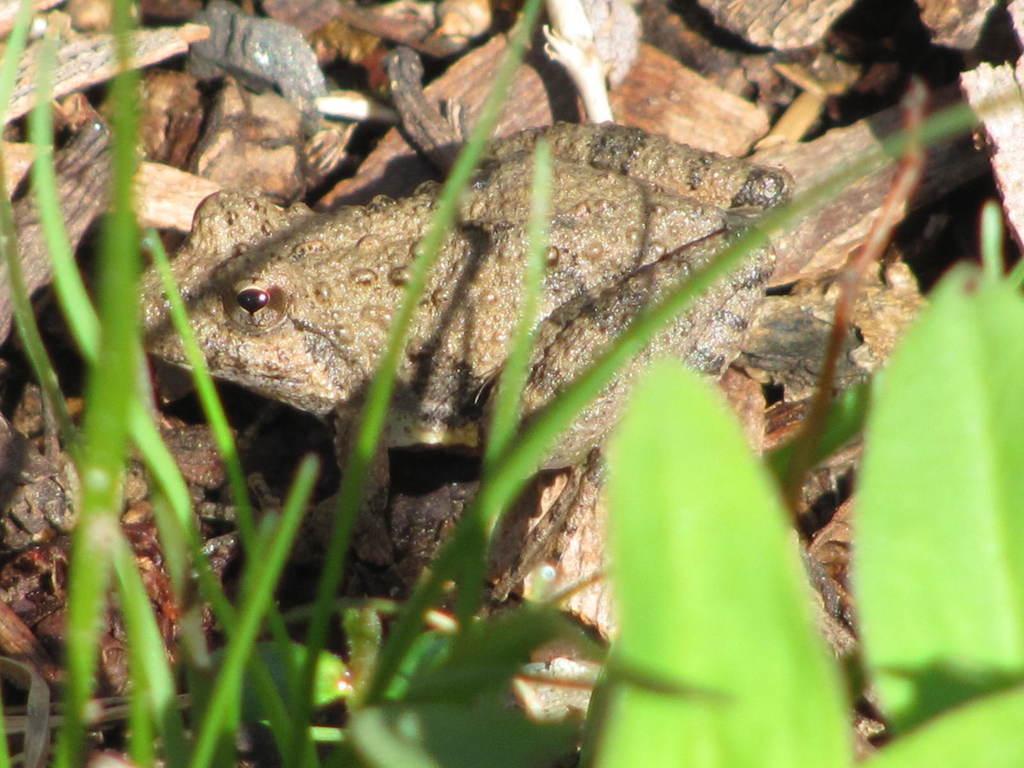Could you give a brief overview of what you see in this image? In this picture we can see a frog and leaves. 